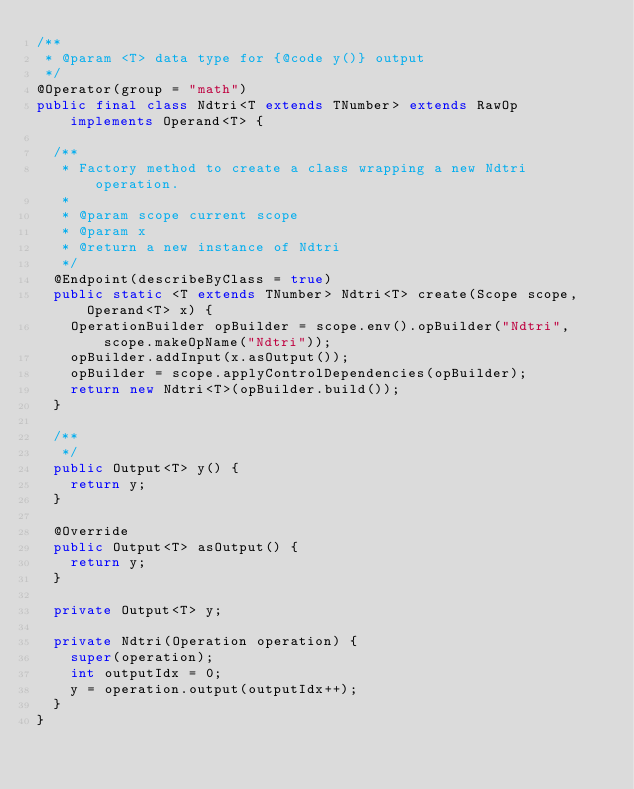Convert code to text. <code><loc_0><loc_0><loc_500><loc_500><_Java_>/**
 * @param <T> data type for {@code y()} output
 */
@Operator(group = "math")
public final class Ndtri<T extends TNumber> extends RawOp implements Operand<T> {
  
  /**
   * Factory method to create a class wrapping a new Ndtri operation.
   * 
   * @param scope current scope
   * @param x 
   * @return a new instance of Ndtri
   */
  @Endpoint(describeByClass = true)
  public static <T extends TNumber> Ndtri<T> create(Scope scope, Operand<T> x) {
    OperationBuilder opBuilder = scope.env().opBuilder("Ndtri", scope.makeOpName("Ndtri"));
    opBuilder.addInput(x.asOutput());
    opBuilder = scope.applyControlDependencies(opBuilder);
    return new Ndtri<T>(opBuilder.build());
  }
  
  /**
   */
  public Output<T> y() {
    return y;
  }
  
  @Override
  public Output<T> asOutput() {
    return y;
  }
  
  private Output<T> y;
  
  private Ndtri(Operation operation) {
    super(operation);
    int outputIdx = 0;
    y = operation.output(outputIdx++);
  }
}
</code> 